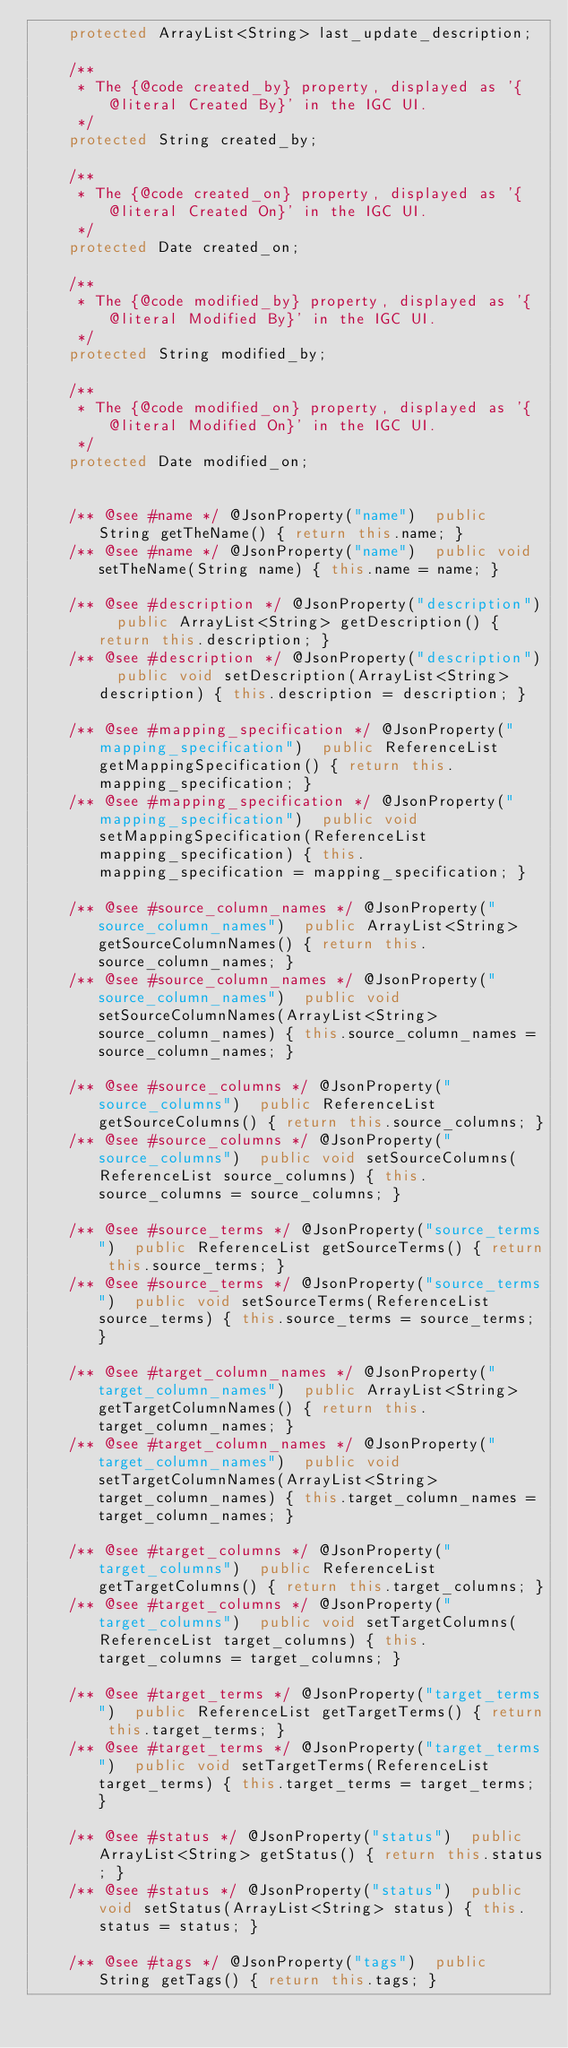<code> <loc_0><loc_0><loc_500><loc_500><_Java_>    protected ArrayList<String> last_update_description;

    /**
     * The {@code created_by} property, displayed as '{@literal Created By}' in the IGC UI.
     */
    protected String created_by;

    /**
     * The {@code created_on} property, displayed as '{@literal Created On}' in the IGC UI.
     */
    protected Date created_on;

    /**
     * The {@code modified_by} property, displayed as '{@literal Modified By}' in the IGC UI.
     */
    protected String modified_by;

    /**
     * The {@code modified_on} property, displayed as '{@literal Modified On}' in the IGC UI.
     */
    protected Date modified_on;


    /** @see #name */ @JsonProperty("name")  public String getTheName() { return this.name; }
    /** @see #name */ @JsonProperty("name")  public void setTheName(String name) { this.name = name; }

    /** @see #description */ @JsonProperty("description")  public ArrayList<String> getDescription() { return this.description; }
    /** @see #description */ @JsonProperty("description")  public void setDescription(ArrayList<String> description) { this.description = description; }

    /** @see #mapping_specification */ @JsonProperty("mapping_specification")  public ReferenceList getMappingSpecification() { return this.mapping_specification; }
    /** @see #mapping_specification */ @JsonProperty("mapping_specification")  public void setMappingSpecification(ReferenceList mapping_specification) { this.mapping_specification = mapping_specification; }

    /** @see #source_column_names */ @JsonProperty("source_column_names")  public ArrayList<String> getSourceColumnNames() { return this.source_column_names; }
    /** @see #source_column_names */ @JsonProperty("source_column_names")  public void setSourceColumnNames(ArrayList<String> source_column_names) { this.source_column_names = source_column_names; }

    /** @see #source_columns */ @JsonProperty("source_columns")  public ReferenceList getSourceColumns() { return this.source_columns; }
    /** @see #source_columns */ @JsonProperty("source_columns")  public void setSourceColumns(ReferenceList source_columns) { this.source_columns = source_columns; }

    /** @see #source_terms */ @JsonProperty("source_terms")  public ReferenceList getSourceTerms() { return this.source_terms; }
    /** @see #source_terms */ @JsonProperty("source_terms")  public void setSourceTerms(ReferenceList source_terms) { this.source_terms = source_terms; }

    /** @see #target_column_names */ @JsonProperty("target_column_names")  public ArrayList<String> getTargetColumnNames() { return this.target_column_names; }
    /** @see #target_column_names */ @JsonProperty("target_column_names")  public void setTargetColumnNames(ArrayList<String> target_column_names) { this.target_column_names = target_column_names; }

    /** @see #target_columns */ @JsonProperty("target_columns")  public ReferenceList getTargetColumns() { return this.target_columns; }
    /** @see #target_columns */ @JsonProperty("target_columns")  public void setTargetColumns(ReferenceList target_columns) { this.target_columns = target_columns; }

    /** @see #target_terms */ @JsonProperty("target_terms")  public ReferenceList getTargetTerms() { return this.target_terms; }
    /** @see #target_terms */ @JsonProperty("target_terms")  public void setTargetTerms(ReferenceList target_terms) { this.target_terms = target_terms; }

    /** @see #status */ @JsonProperty("status")  public ArrayList<String> getStatus() { return this.status; }
    /** @see #status */ @JsonProperty("status")  public void setStatus(ArrayList<String> status) { this.status = status; }

    /** @see #tags */ @JsonProperty("tags")  public String getTags() { return this.tags; }</code> 